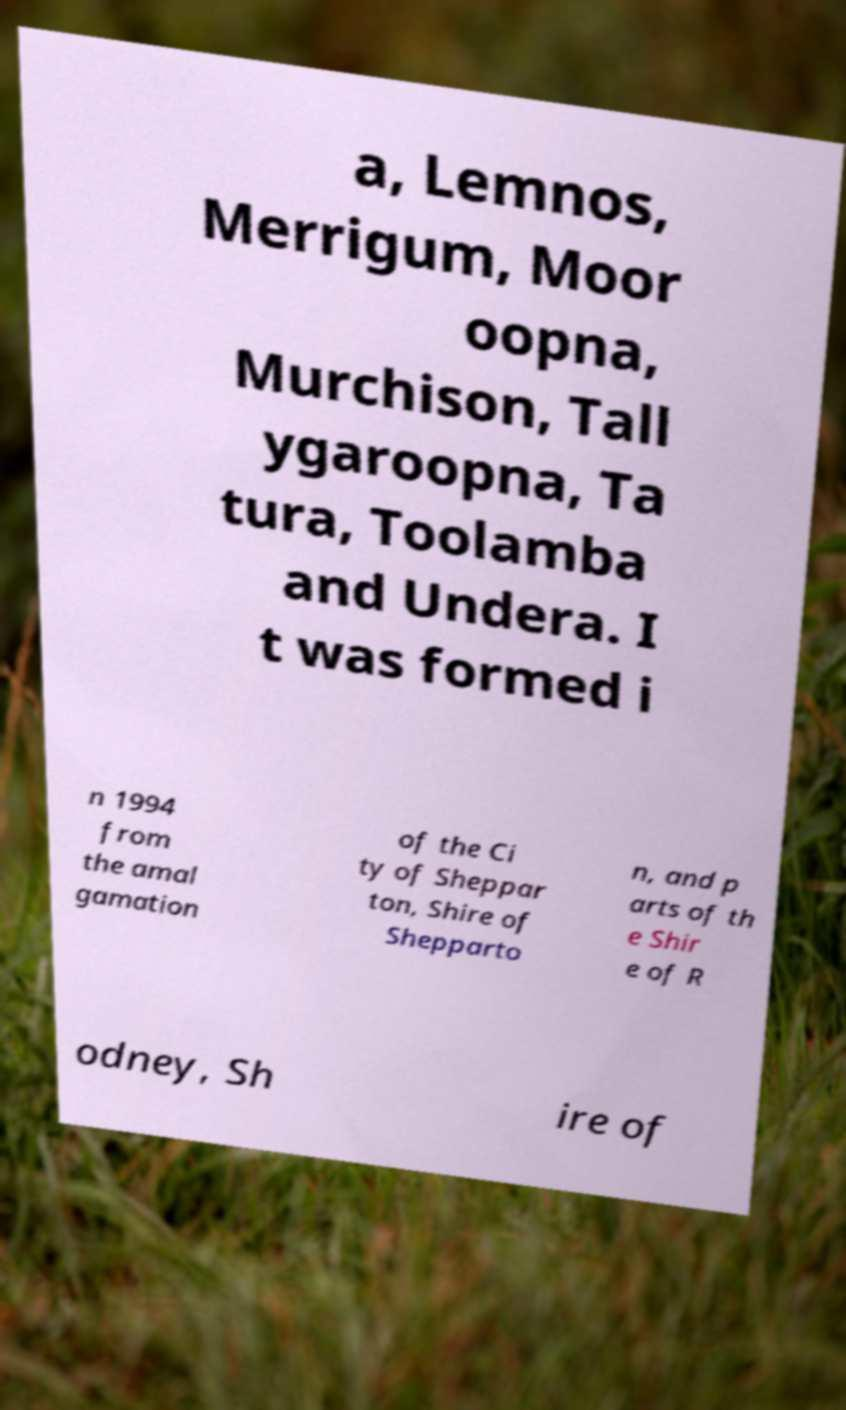For documentation purposes, I need the text within this image transcribed. Could you provide that? a, Lemnos, Merrigum, Moor oopna, Murchison, Tall ygaroopna, Ta tura, Toolamba and Undera. I t was formed i n 1994 from the amal gamation of the Ci ty of Sheppar ton, Shire of Shepparto n, and p arts of th e Shir e of R odney, Sh ire of 